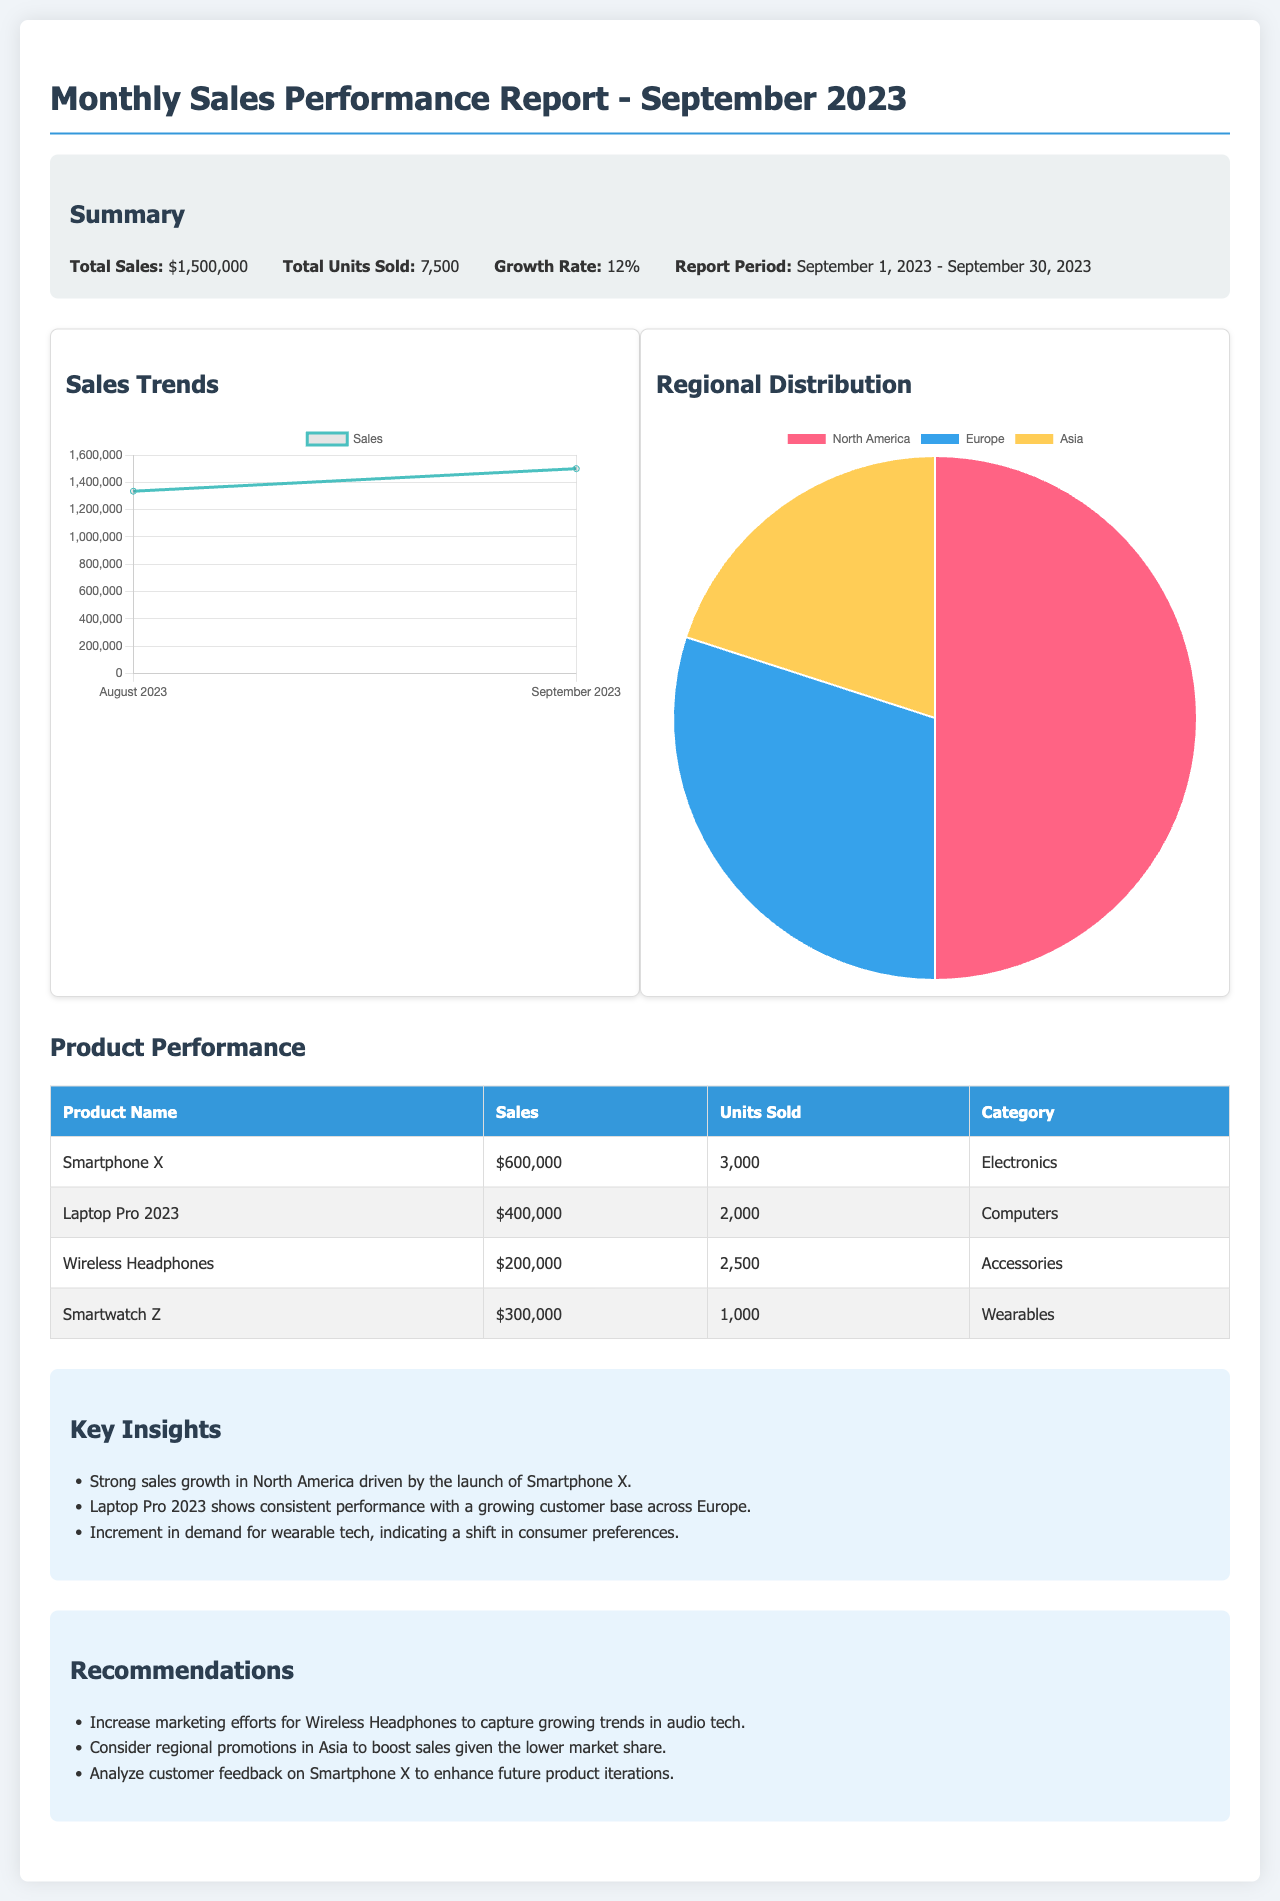What is the total sales for September 2023? The total sales is explicitly stated in the summary section of the report.
Answer: $1,500,000 How many units were sold in September 2023? The total units sold is mentioned in the summary section of the report.
Answer: 7,500 What is the growth rate for September 2023? The growth rate is provided in the summary section.
Answer: 12% Which product generated the highest sales? The product with the highest sales is listed in the product performance table.
Answer: Smartphone X What percentage of total sales came from North America? The regional distribution chart indicates the percentage of sales from North America.
Answer: 50% What were the sales for Wireless Headphones? The sales figure for Wireless Headphones is provided in the product performance table.
Answer: $200,000 What recommendation is given for Wireless Headphones? The recommendations section mentions a specific action regarding Wireless Headphones.
Answer: Increase marketing efforts Which region shows the lowest market share? The insights section hints at a region with lower performance.
Answer: Asia How many units of Laptop Pro 2023 were sold? The total units sold for Laptop Pro 2023 is recorded in the product performance table.
Answer: 2,000 